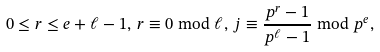Convert formula to latex. <formula><loc_0><loc_0><loc_500><loc_500>0 \leq r \leq e + \ell - 1 , \, r \equiv 0 \bmod { \ell } , \, j \equiv \frac { p ^ { r } - 1 } { p ^ { \ell } - 1 } \bmod { p ^ { e } } ,</formula> 